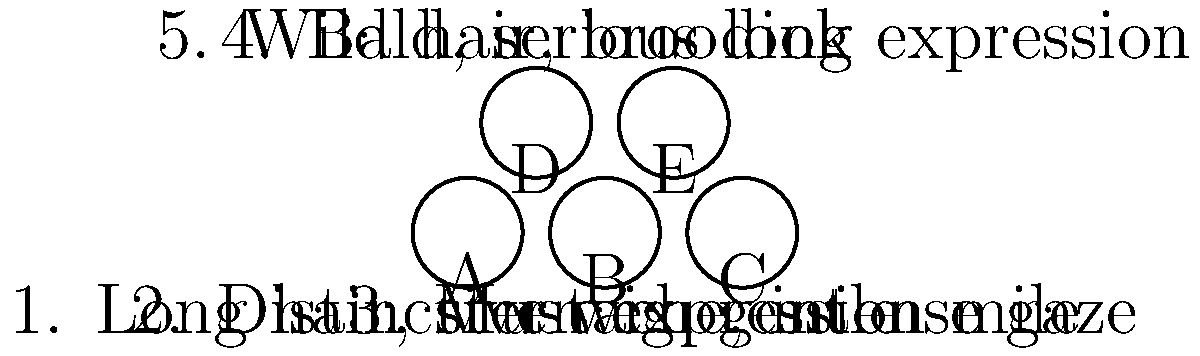Match the following composers to their portraits (A-E) based on the given descriptions:

a) Ludwig van Beethoven
b) Wolfgang Amadeus Mozart
c) Johann Sebastian Bach
d) Frédéric Chopin
e) Richard Wagner

Which portrait (A-E) corresponds to the composer known for his "Moonlight Sonata" and "Ode to Joy"? To answer this question, let's analyze each composer and their corresponding description:

1. Ludwig van Beethoven: Known for wild hair and a brooding expression. This matches description 5 and portrait E.
2. Wolfgang Amadeus Mozart: Often depicted with a distinctive wig and gentle smile. This corresponds to description 2 and portrait B.
3. Johann Sebastian Bach: Usually portrayed with a long-haired wig and stern expression. This fits description 1 and portrait A.
4. Frédéric Chopin: Typically shown with a mustache and intense gaze. This aligns with description 3 and portrait C.
5. Richard Wagner: Often depicted as bald with a serious look. This matches description 4 and portrait D.

The question asks specifically about the composer known for "Moonlight Sonata" and "Ode to Joy." These are two of Beethoven's most famous works. As we identified earlier, Beethoven corresponds to portrait E.
Answer: E 